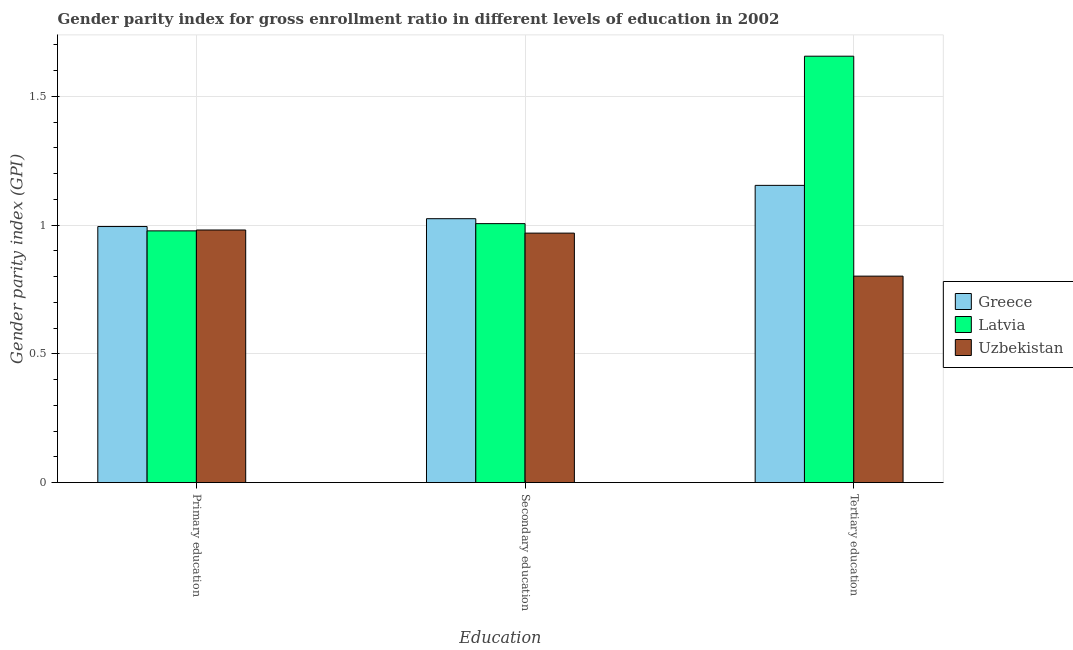How many groups of bars are there?
Give a very brief answer. 3. How many bars are there on the 3rd tick from the right?
Your answer should be compact. 3. What is the label of the 2nd group of bars from the left?
Give a very brief answer. Secondary education. What is the gender parity index in tertiary education in Latvia?
Provide a short and direct response. 1.66. Across all countries, what is the maximum gender parity index in primary education?
Ensure brevity in your answer.  0.99. Across all countries, what is the minimum gender parity index in secondary education?
Keep it short and to the point. 0.97. In which country was the gender parity index in tertiary education maximum?
Give a very brief answer. Latvia. In which country was the gender parity index in primary education minimum?
Give a very brief answer. Latvia. What is the total gender parity index in secondary education in the graph?
Offer a terse response. 3. What is the difference between the gender parity index in secondary education in Latvia and that in Uzbekistan?
Your answer should be compact. 0.04. What is the difference between the gender parity index in tertiary education in Uzbekistan and the gender parity index in primary education in Latvia?
Offer a very short reply. -0.18. What is the average gender parity index in tertiary education per country?
Give a very brief answer. 1.2. What is the difference between the gender parity index in secondary education and gender parity index in tertiary education in Uzbekistan?
Ensure brevity in your answer.  0.17. In how many countries, is the gender parity index in primary education greater than 0.30000000000000004 ?
Ensure brevity in your answer.  3. What is the ratio of the gender parity index in primary education in Latvia to that in Greece?
Your response must be concise. 0.98. Is the gender parity index in primary education in Latvia less than that in Greece?
Your answer should be compact. Yes. Is the difference between the gender parity index in secondary education in Uzbekistan and Greece greater than the difference between the gender parity index in primary education in Uzbekistan and Greece?
Offer a very short reply. No. What is the difference between the highest and the second highest gender parity index in tertiary education?
Your answer should be compact. 0.5. What is the difference between the highest and the lowest gender parity index in primary education?
Your response must be concise. 0.02. In how many countries, is the gender parity index in tertiary education greater than the average gender parity index in tertiary education taken over all countries?
Keep it short and to the point. 1. Is the sum of the gender parity index in tertiary education in Latvia and Greece greater than the maximum gender parity index in secondary education across all countries?
Keep it short and to the point. Yes. What does the 2nd bar from the left in Tertiary education represents?
Ensure brevity in your answer.  Latvia. What does the 2nd bar from the right in Tertiary education represents?
Ensure brevity in your answer.  Latvia. Is it the case that in every country, the sum of the gender parity index in primary education and gender parity index in secondary education is greater than the gender parity index in tertiary education?
Offer a very short reply. Yes. Are all the bars in the graph horizontal?
Provide a succinct answer. No. How many countries are there in the graph?
Give a very brief answer. 3. What is the difference between two consecutive major ticks on the Y-axis?
Provide a succinct answer. 0.5. Are the values on the major ticks of Y-axis written in scientific E-notation?
Ensure brevity in your answer.  No. Does the graph contain any zero values?
Your response must be concise. No. Where does the legend appear in the graph?
Offer a very short reply. Center right. How many legend labels are there?
Offer a terse response. 3. How are the legend labels stacked?
Provide a succinct answer. Vertical. What is the title of the graph?
Your answer should be very brief. Gender parity index for gross enrollment ratio in different levels of education in 2002. Does "Ethiopia" appear as one of the legend labels in the graph?
Keep it short and to the point. No. What is the label or title of the X-axis?
Keep it short and to the point. Education. What is the label or title of the Y-axis?
Offer a terse response. Gender parity index (GPI). What is the Gender parity index (GPI) of Greece in Primary education?
Offer a terse response. 0.99. What is the Gender parity index (GPI) in Latvia in Primary education?
Provide a short and direct response. 0.98. What is the Gender parity index (GPI) in Uzbekistan in Primary education?
Provide a succinct answer. 0.98. What is the Gender parity index (GPI) in Greece in Secondary education?
Offer a very short reply. 1.02. What is the Gender parity index (GPI) in Latvia in Secondary education?
Provide a succinct answer. 1.01. What is the Gender parity index (GPI) of Uzbekistan in Secondary education?
Your answer should be compact. 0.97. What is the Gender parity index (GPI) of Greece in Tertiary education?
Your answer should be compact. 1.15. What is the Gender parity index (GPI) in Latvia in Tertiary education?
Provide a succinct answer. 1.66. What is the Gender parity index (GPI) in Uzbekistan in Tertiary education?
Your answer should be compact. 0.8. Across all Education, what is the maximum Gender parity index (GPI) of Greece?
Offer a very short reply. 1.15. Across all Education, what is the maximum Gender parity index (GPI) of Latvia?
Your response must be concise. 1.66. Across all Education, what is the maximum Gender parity index (GPI) in Uzbekistan?
Offer a very short reply. 0.98. Across all Education, what is the minimum Gender parity index (GPI) in Greece?
Keep it short and to the point. 0.99. Across all Education, what is the minimum Gender parity index (GPI) of Latvia?
Your answer should be compact. 0.98. Across all Education, what is the minimum Gender parity index (GPI) of Uzbekistan?
Ensure brevity in your answer.  0.8. What is the total Gender parity index (GPI) of Greece in the graph?
Provide a short and direct response. 3.17. What is the total Gender parity index (GPI) in Latvia in the graph?
Ensure brevity in your answer.  3.64. What is the total Gender parity index (GPI) of Uzbekistan in the graph?
Make the answer very short. 2.75. What is the difference between the Gender parity index (GPI) in Greece in Primary education and that in Secondary education?
Give a very brief answer. -0.03. What is the difference between the Gender parity index (GPI) in Latvia in Primary education and that in Secondary education?
Give a very brief answer. -0.03. What is the difference between the Gender parity index (GPI) of Uzbekistan in Primary education and that in Secondary education?
Give a very brief answer. 0.01. What is the difference between the Gender parity index (GPI) in Greece in Primary education and that in Tertiary education?
Offer a terse response. -0.16. What is the difference between the Gender parity index (GPI) of Latvia in Primary education and that in Tertiary education?
Your answer should be very brief. -0.68. What is the difference between the Gender parity index (GPI) in Uzbekistan in Primary education and that in Tertiary education?
Give a very brief answer. 0.18. What is the difference between the Gender parity index (GPI) of Greece in Secondary education and that in Tertiary education?
Your answer should be very brief. -0.13. What is the difference between the Gender parity index (GPI) of Latvia in Secondary education and that in Tertiary education?
Keep it short and to the point. -0.65. What is the difference between the Gender parity index (GPI) in Uzbekistan in Secondary education and that in Tertiary education?
Your answer should be compact. 0.17. What is the difference between the Gender parity index (GPI) in Greece in Primary education and the Gender parity index (GPI) in Latvia in Secondary education?
Your response must be concise. -0.01. What is the difference between the Gender parity index (GPI) of Greece in Primary education and the Gender parity index (GPI) of Uzbekistan in Secondary education?
Make the answer very short. 0.03. What is the difference between the Gender parity index (GPI) of Latvia in Primary education and the Gender parity index (GPI) of Uzbekistan in Secondary education?
Give a very brief answer. 0.01. What is the difference between the Gender parity index (GPI) of Greece in Primary education and the Gender parity index (GPI) of Latvia in Tertiary education?
Your answer should be very brief. -0.66. What is the difference between the Gender parity index (GPI) of Greece in Primary education and the Gender parity index (GPI) of Uzbekistan in Tertiary education?
Your response must be concise. 0.19. What is the difference between the Gender parity index (GPI) in Latvia in Primary education and the Gender parity index (GPI) in Uzbekistan in Tertiary education?
Offer a terse response. 0.18. What is the difference between the Gender parity index (GPI) of Greece in Secondary education and the Gender parity index (GPI) of Latvia in Tertiary education?
Offer a very short reply. -0.63. What is the difference between the Gender parity index (GPI) in Greece in Secondary education and the Gender parity index (GPI) in Uzbekistan in Tertiary education?
Offer a very short reply. 0.22. What is the difference between the Gender parity index (GPI) in Latvia in Secondary education and the Gender parity index (GPI) in Uzbekistan in Tertiary education?
Your response must be concise. 0.2. What is the average Gender parity index (GPI) of Greece per Education?
Give a very brief answer. 1.06. What is the average Gender parity index (GPI) in Latvia per Education?
Offer a terse response. 1.21. What is the average Gender parity index (GPI) of Uzbekistan per Education?
Ensure brevity in your answer.  0.92. What is the difference between the Gender parity index (GPI) in Greece and Gender parity index (GPI) in Latvia in Primary education?
Ensure brevity in your answer.  0.02. What is the difference between the Gender parity index (GPI) of Greece and Gender parity index (GPI) of Uzbekistan in Primary education?
Provide a short and direct response. 0.01. What is the difference between the Gender parity index (GPI) of Latvia and Gender parity index (GPI) of Uzbekistan in Primary education?
Provide a succinct answer. -0. What is the difference between the Gender parity index (GPI) of Greece and Gender parity index (GPI) of Latvia in Secondary education?
Offer a terse response. 0.02. What is the difference between the Gender parity index (GPI) of Greece and Gender parity index (GPI) of Uzbekistan in Secondary education?
Provide a short and direct response. 0.06. What is the difference between the Gender parity index (GPI) of Latvia and Gender parity index (GPI) of Uzbekistan in Secondary education?
Give a very brief answer. 0.04. What is the difference between the Gender parity index (GPI) in Greece and Gender parity index (GPI) in Latvia in Tertiary education?
Keep it short and to the point. -0.5. What is the difference between the Gender parity index (GPI) of Greece and Gender parity index (GPI) of Uzbekistan in Tertiary education?
Provide a short and direct response. 0.35. What is the difference between the Gender parity index (GPI) in Latvia and Gender parity index (GPI) in Uzbekistan in Tertiary education?
Offer a terse response. 0.85. What is the ratio of the Gender parity index (GPI) of Greece in Primary education to that in Secondary education?
Ensure brevity in your answer.  0.97. What is the ratio of the Gender parity index (GPI) in Latvia in Primary education to that in Secondary education?
Provide a succinct answer. 0.97. What is the ratio of the Gender parity index (GPI) in Uzbekistan in Primary education to that in Secondary education?
Give a very brief answer. 1.01. What is the ratio of the Gender parity index (GPI) in Greece in Primary education to that in Tertiary education?
Offer a very short reply. 0.86. What is the ratio of the Gender parity index (GPI) in Latvia in Primary education to that in Tertiary education?
Your answer should be very brief. 0.59. What is the ratio of the Gender parity index (GPI) of Uzbekistan in Primary education to that in Tertiary education?
Offer a terse response. 1.22. What is the ratio of the Gender parity index (GPI) in Greece in Secondary education to that in Tertiary education?
Your answer should be very brief. 0.89. What is the ratio of the Gender parity index (GPI) in Latvia in Secondary education to that in Tertiary education?
Your answer should be compact. 0.61. What is the ratio of the Gender parity index (GPI) in Uzbekistan in Secondary education to that in Tertiary education?
Keep it short and to the point. 1.21. What is the difference between the highest and the second highest Gender parity index (GPI) of Greece?
Make the answer very short. 0.13. What is the difference between the highest and the second highest Gender parity index (GPI) in Latvia?
Give a very brief answer. 0.65. What is the difference between the highest and the second highest Gender parity index (GPI) of Uzbekistan?
Keep it short and to the point. 0.01. What is the difference between the highest and the lowest Gender parity index (GPI) in Greece?
Offer a terse response. 0.16. What is the difference between the highest and the lowest Gender parity index (GPI) in Latvia?
Your answer should be compact. 0.68. What is the difference between the highest and the lowest Gender parity index (GPI) of Uzbekistan?
Provide a short and direct response. 0.18. 